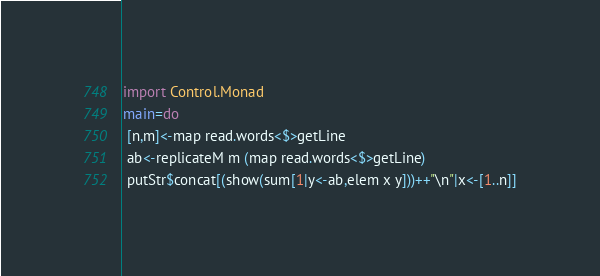Convert code to text. <code><loc_0><loc_0><loc_500><loc_500><_Haskell_>import Control.Monad
main=do
 [n,m]<-map read.words<$>getLine
 ab<-replicateM m (map read.words<$>getLine)
 putStr$concat[(show(sum[1|y<-ab,elem x y]))++"\n"|x<-[1..n]]</code> 